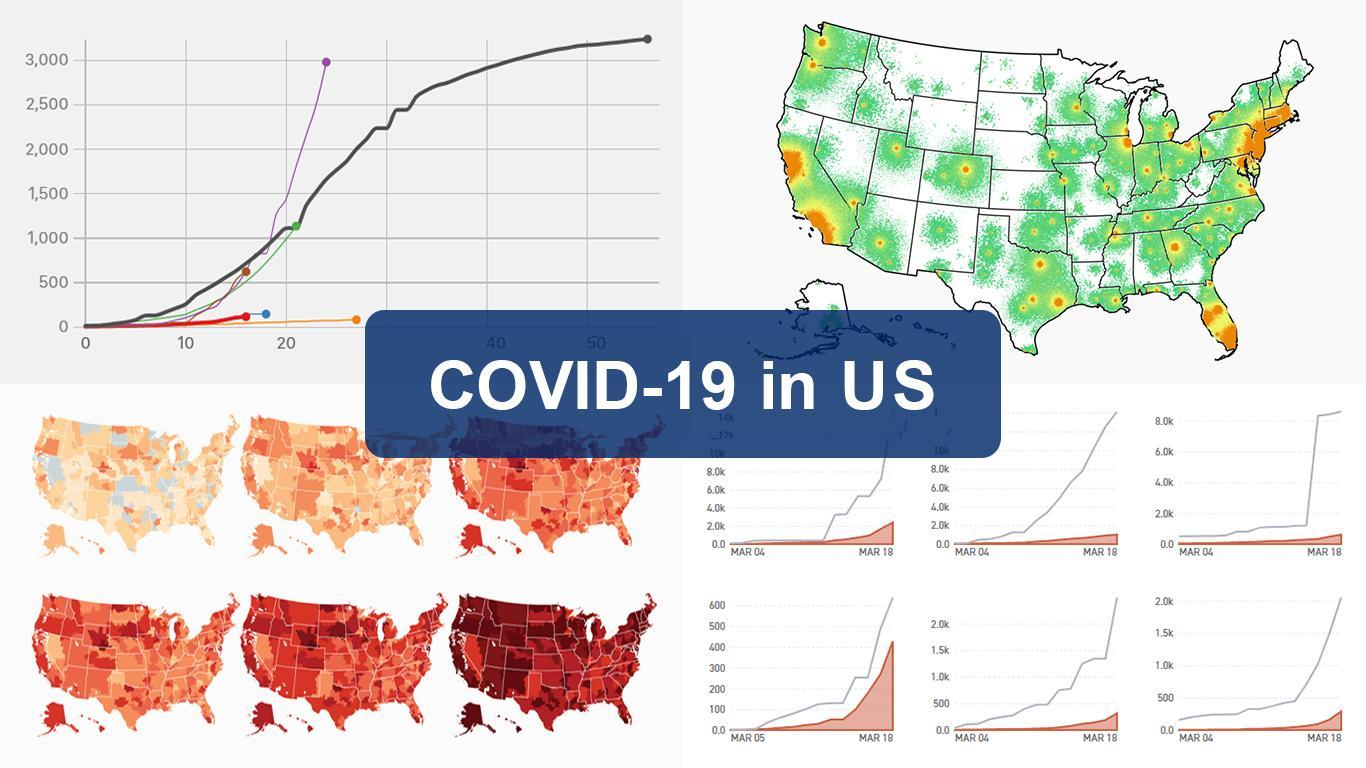How many maps are in this infographic?
Answer the question with a short phrase. 7 